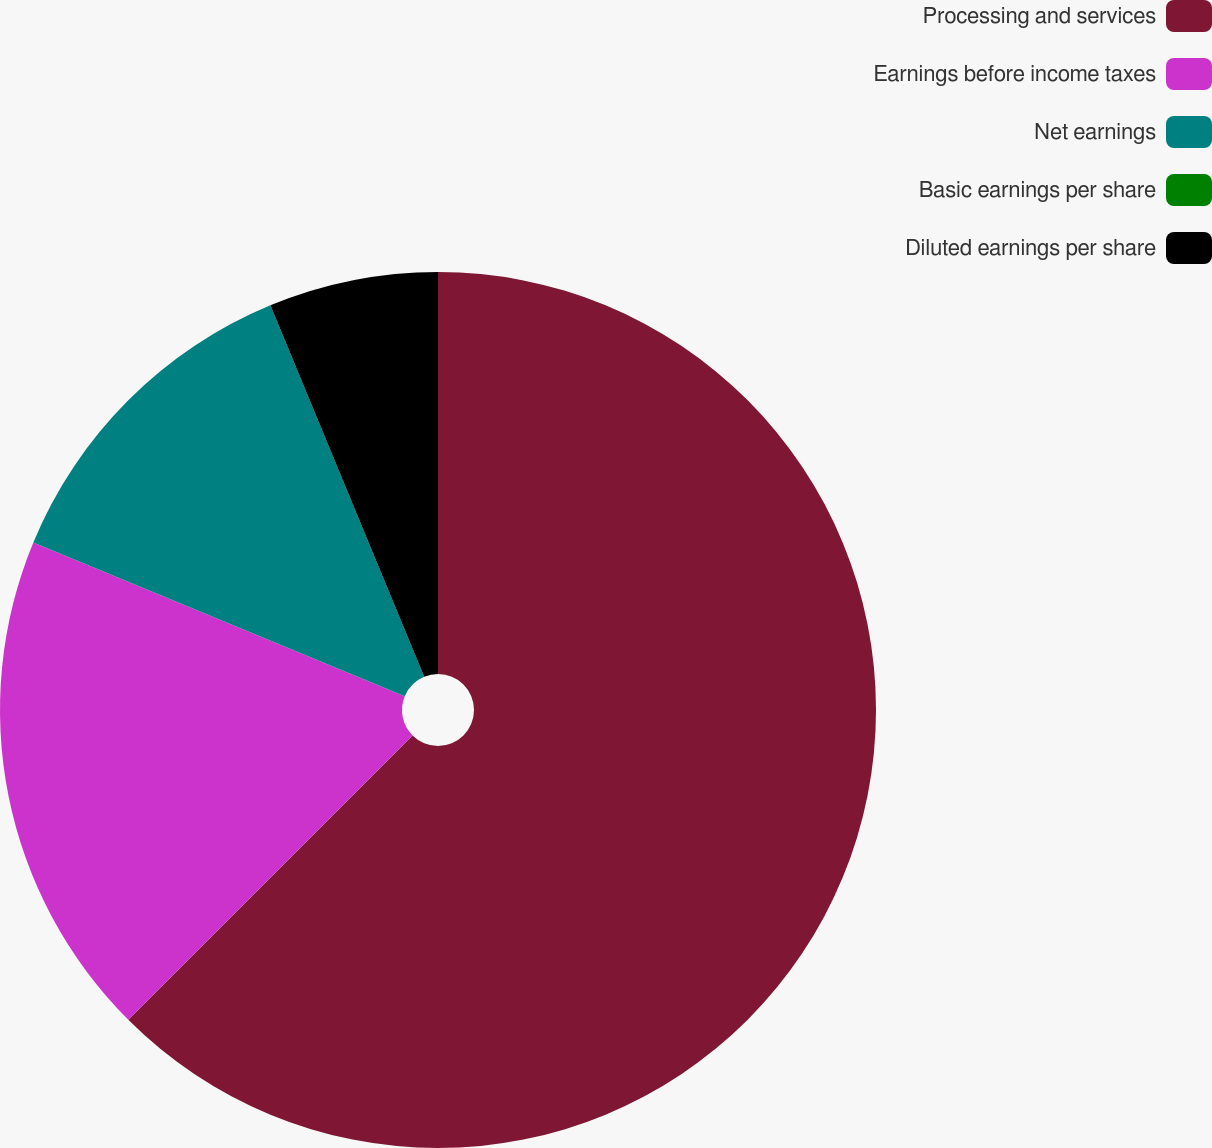Convert chart to OTSL. <chart><loc_0><loc_0><loc_500><loc_500><pie_chart><fcel>Processing and services<fcel>Earnings before income taxes<fcel>Net earnings<fcel>Basic earnings per share<fcel>Diluted earnings per share<nl><fcel>62.5%<fcel>18.75%<fcel>12.5%<fcel>0.0%<fcel>6.25%<nl></chart> 